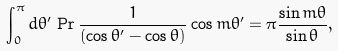<formula> <loc_0><loc_0><loc_500><loc_500>\int _ { 0 } ^ { \pi } d \theta ^ { \prime } \, \Pr \frac { 1 } { ( \cos \theta ^ { \prime } - \cos \theta ) } \cos m \theta ^ { \prime } = \pi \frac { \sin m \theta } { \sin \theta } ,</formula> 